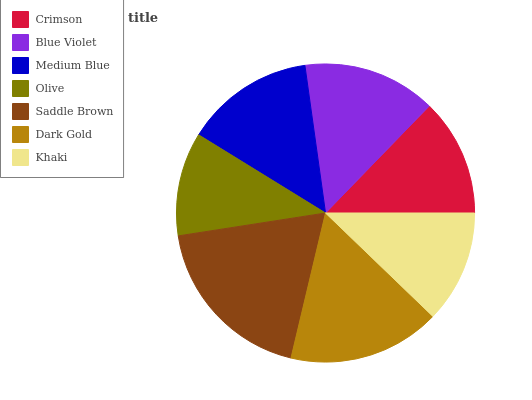Is Olive the minimum?
Answer yes or no. Yes. Is Saddle Brown the maximum?
Answer yes or no. Yes. Is Blue Violet the minimum?
Answer yes or no. No. Is Blue Violet the maximum?
Answer yes or no. No. Is Blue Violet greater than Crimson?
Answer yes or no. Yes. Is Crimson less than Blue Violet?
Answer yes or no. Yes. Is Crimson greater than Blue Violet?
Answer yes or no. No. Is Blue Violet less than Crimson?
Answer yes or no. No. Is Medium Blue the high median?
Answer yes or no. Yes. Is Medium Blue the low median?
Answer yes or no. Yes. Is Saddle Brown the high median?
Answer yes or no. No. Is Khaki the low median?
Answer yes or no. No. 